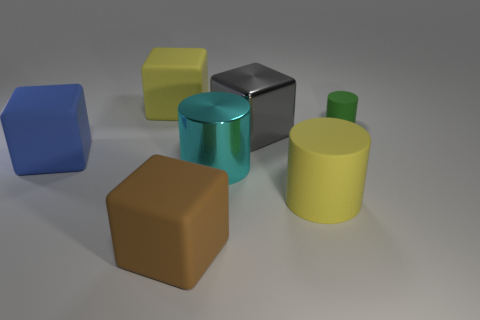What number of other things are made of the same material as the green thing?
Make the answer very short. 4. Is the size of the yellow matte object that is in front of the green object the same as the small green cylinder?
Your answer should be compact. No. There is a rubber object that is both on the left side of the green rubber cylinder and to the right of the brown object; what is its color?
Offer a terse response. Yellow. The brown thing that is the same size as the gray thing is what shape?
Ensure brevity in your answer.  Cube. Is there a large rubber cube of the same color as the big rubber cylinder?
Keep it short and to the point. Yes. Are there an equal number of tiny rubber objects that are left of the shiny cube and tiny red rubber spheres?
Offer a terse response. Yes. What size is the thing that is in front of the cyan cylinder and left of the large cyan shiny cylinder?
Provide a succinct answer. Large. What color is the other cylinder that is made of the same material as the yellow cylinder?
Offer a terse response. Green. What number of small objects are made of the same material as the big yellow cylinder?
Provide a succinct answer. 1. Is the number of cyan metallic cylinders that are right of the big metallic block the same as the number of blue matte blocks that are to the right of the tiny green cylinder?
Offer a terse response. Yes. 